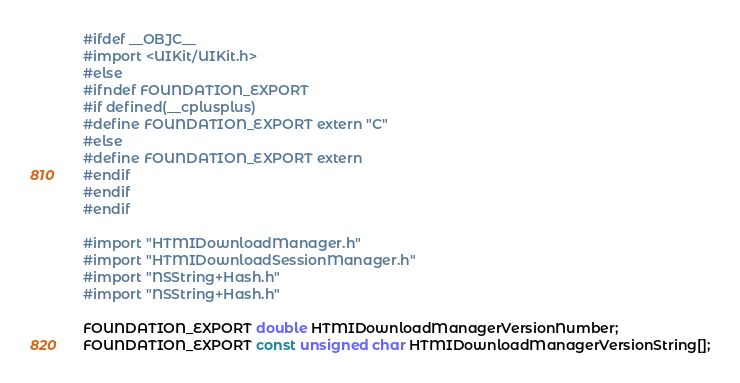Convert code to text. <code><loc_0><loc_0><loc_500><loc_500><_C_>#ifdef __OBJC__
#import <UIKit/UIKit.h>
#else
#ifndef FOUNDATION_EXPORT
#if defined(__cplusplus)
#define FOUNDATION_EXPORT extern "C"
#else
#define FOUNDATION_EXPORT extern
#endif
#endif
#endif

#import "HTMIDownloadManager.h"
#import "HTMIDownloadSessionManager.h"
#import "NSString+Hash.h"
#import "NSString+Hash.h"

FOUNDATION_EXPORT double HTMIDownloadManagerVersionNumber;
FOUNDATION_EXPORT const unsigned char HTMIDownloadManagerVersionString[];

</code> 